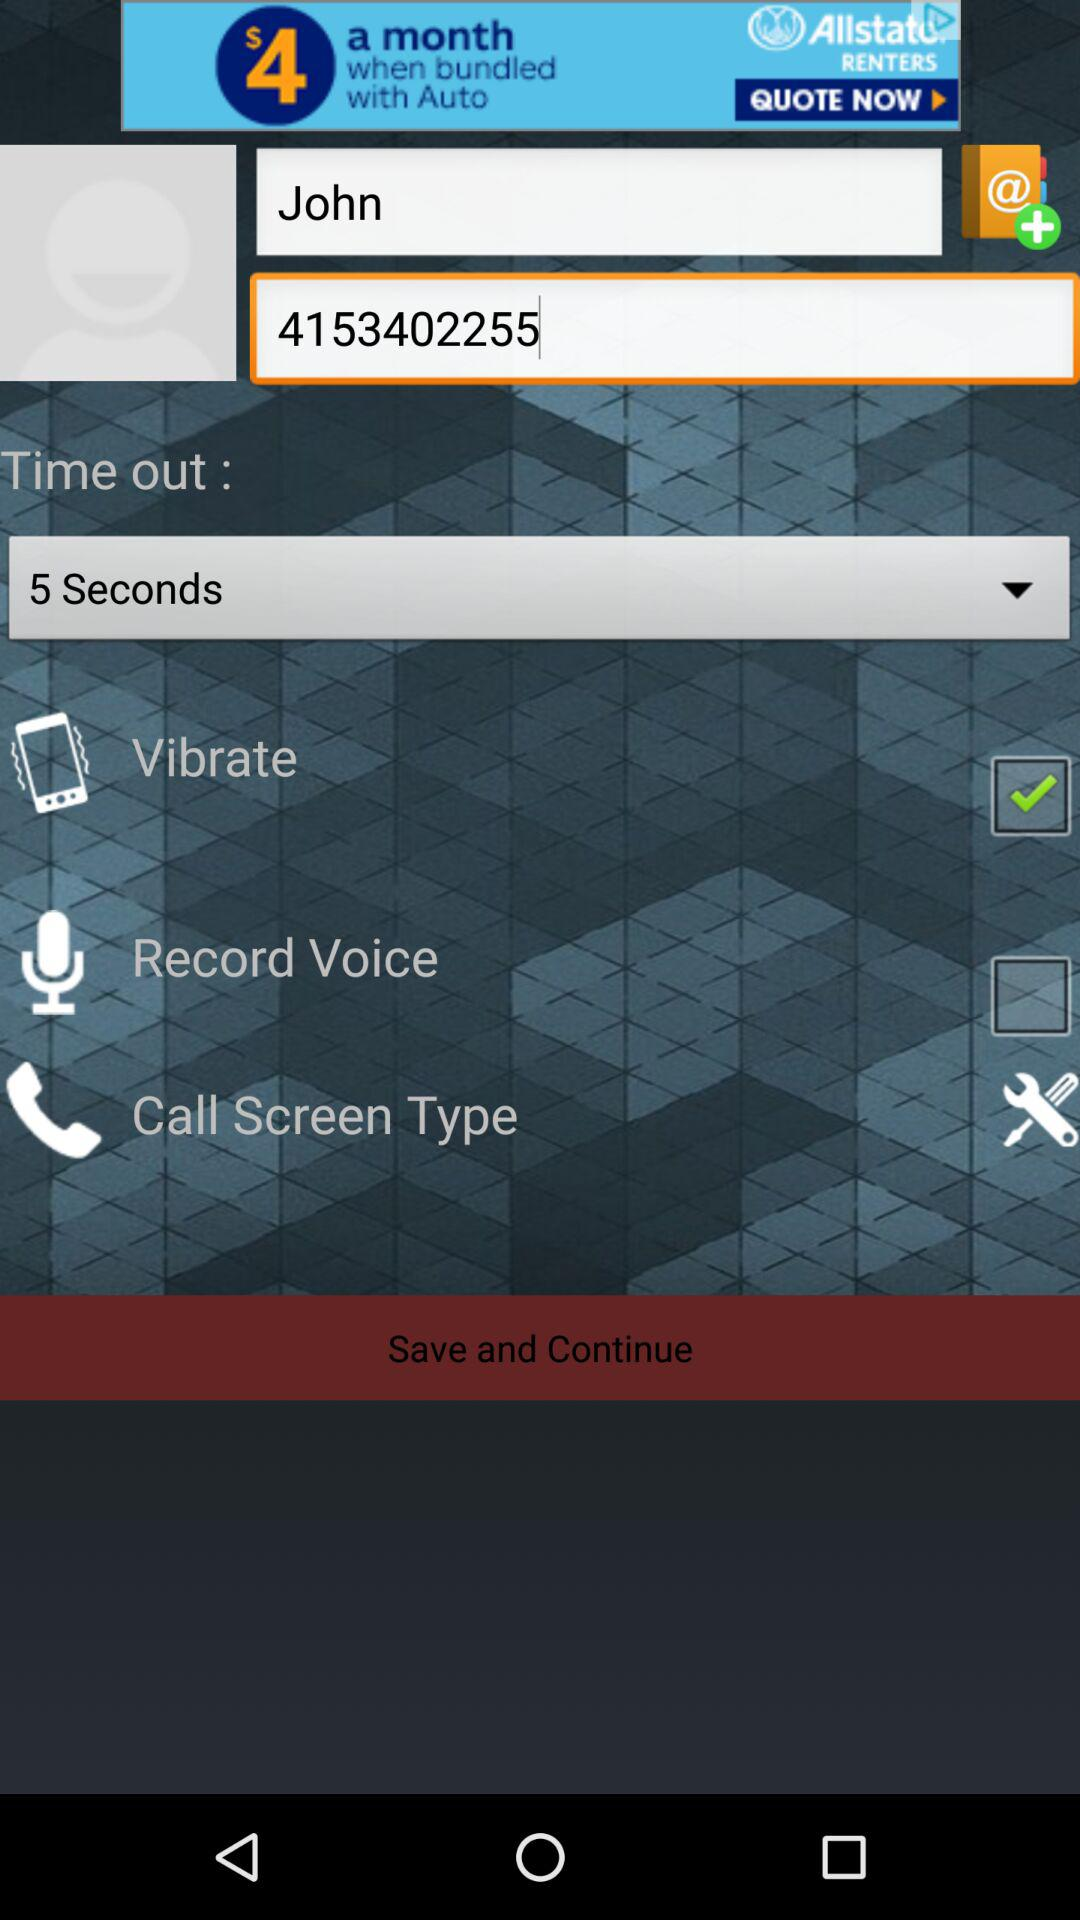What is the set duration for time out? The set duration for time out is 5 seconds. 